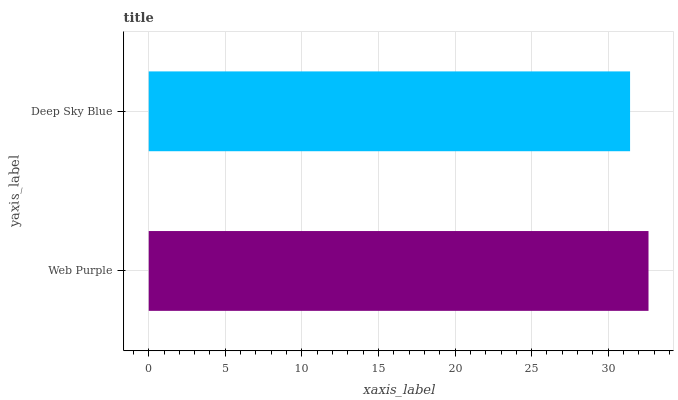Is Deep Sky Blue the minimum?
Answer yes or no. Yes. Is Web Purple the maximum?
Answer yes or no. Yes. Is Deep Sky Blue the maximum?
Answer yes or no. No. Is Web Purple greater than Deep Sky Blue?
Answer yes or no. Yes. Is Deep Sky Blue less than Web Purple?
Answer yes or no. Yes. Is Deep Sky Blue greater than Web Purple?
Answer yes or no. No. Is Web Purple less than Deep Sky Blue?
Answer yes or no. No. Is Web Purple the high median?
Answer yes or no. Yes. Is Deep Sky Blue the low median?
Answer yes or no. Yes. Is Deep Sky Blue the high median?
Answer yes or no. No. Is Web Purple the low median?
Answer yes or no. No. 